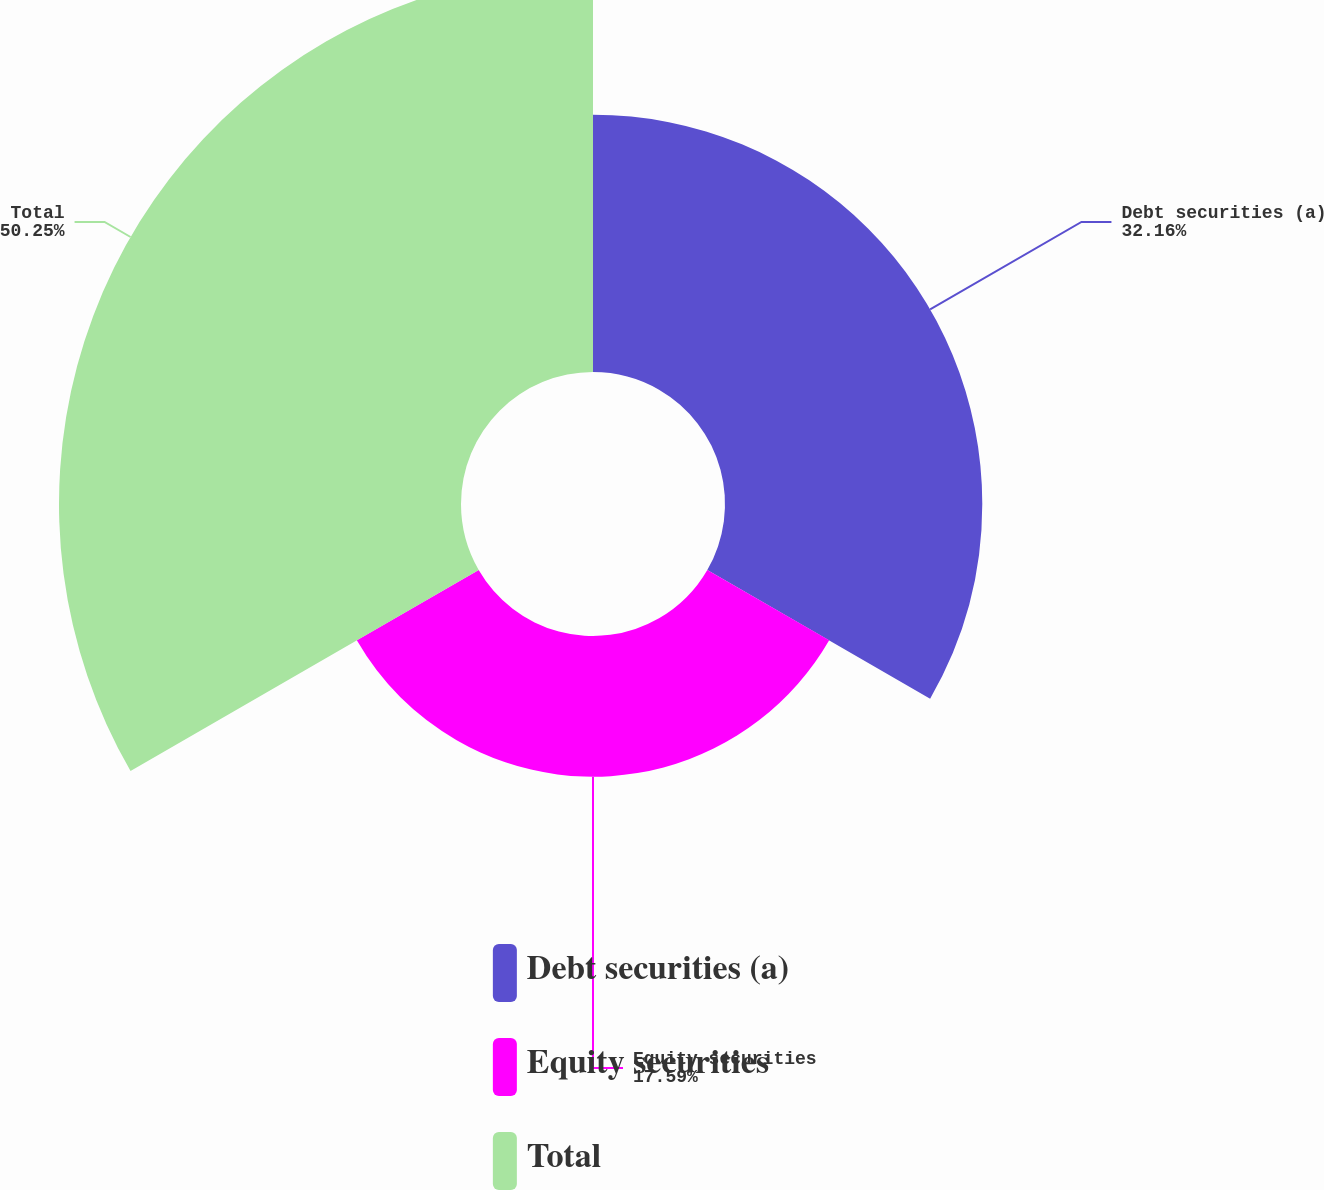Convert chart. <chart><loc_0><loc_0><loc_500><loc_500><pie_chart><fcel>Debt securities (a)<fcel>Equity securities<fcel>Total<nl><fcel>32.16%<fcel>17.59%<fcel>50.25%<nl></chart> 